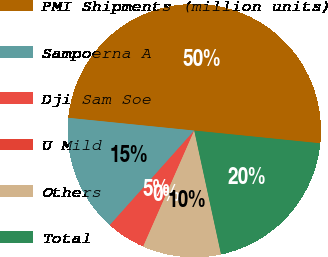Convert chart. <chart><loc_0><loc_0><loc_500><loc_500><pie_chart><fcel>PMI Shipments (million units)<fcel>Sampoerna A<fcel>Dji Sam Soe<fcel>U Mild<fcel>Others<fcel>Total<nl><fcel>50.0%<fcel>15.0%<fcel>5.0%<fcel>0.0%<fcel>10.0%<fcel>20.0%<nl></chart> 